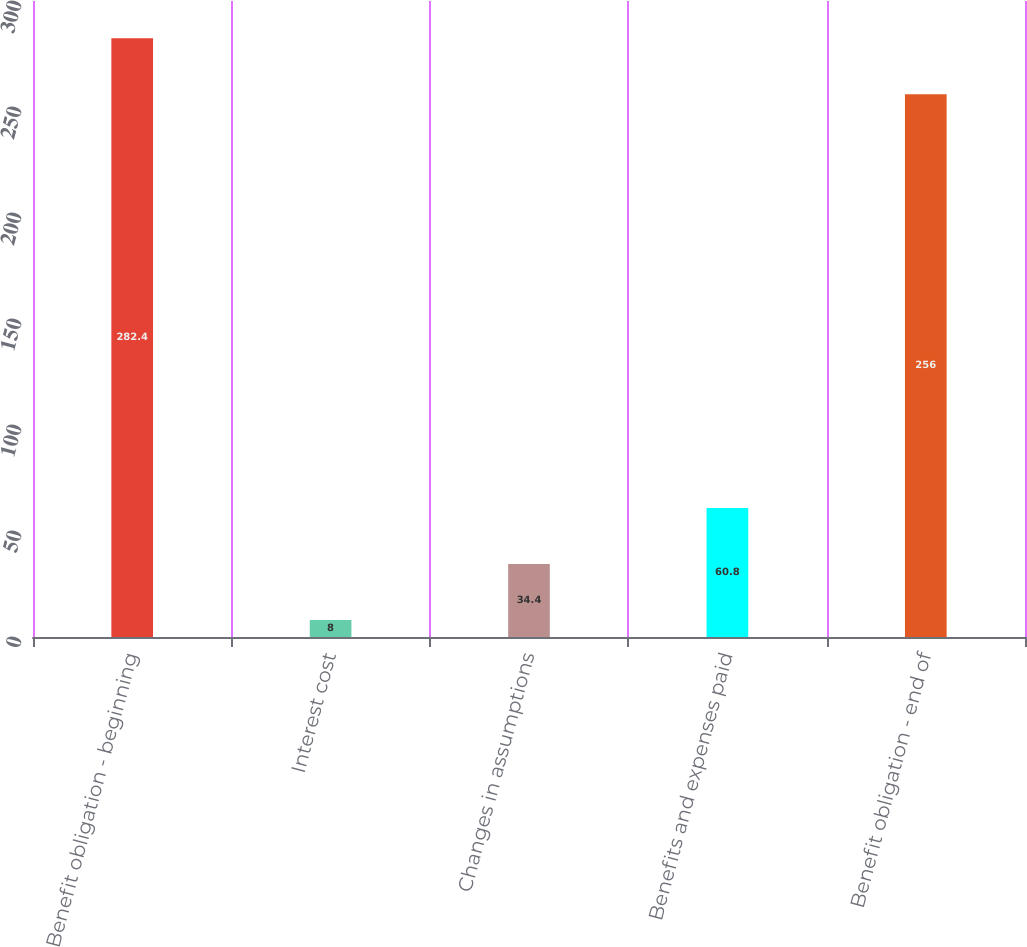Convert chart. <chart><loc_0><loc_0><loc_500><loc_500><bar_chart><fcel>Benefit obligation - beginning<fcel>Interest cost<fcel>Changes in assumptions<fcel>Benefits and expenses paid<fcel>Benefit obligation - end of<nl><fcel>282.4<fcel>8<fcel>34.4<fcel>60.8<fcel>256<nl></chart> 